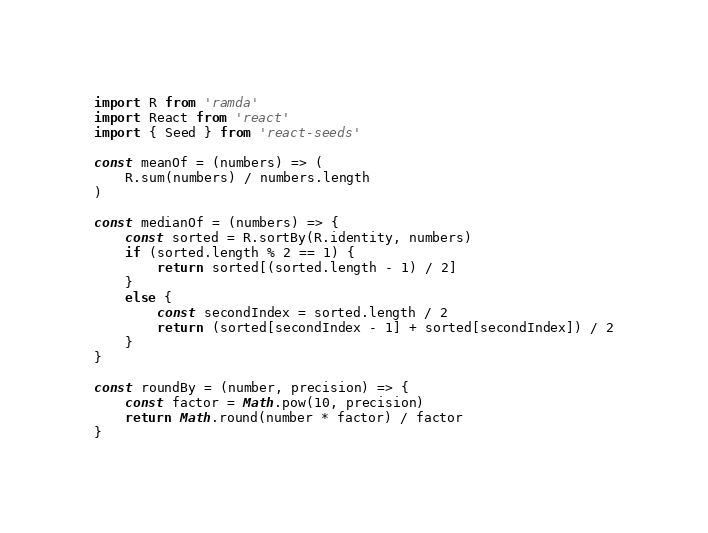Convert code to text. <code><loc_0><loc_0><loc_500><loc_500><_JavaScript_>import R from 'ramda'
import React from 'react'
import { Seed } from 'react-seeds'

const meanOf = (numbers) => (
	R.sum(numbers) / numbers.length
)

const medianOf = (numbers) => {
	const sorted = R.sortBy(R.identity, numbers)
	if (sorted.length % 2 == 1) {
		return sorted[(sorted.length - 1) / 2]
	}
	else {
		const secondIndex = sorted.length / 2 
		return (sorted[secondIndex - 1] + sorted[secondIndex]) / 2
	}
}

const roundBy = (number, precision) => {
	const factor = Math.pow(10, precision)
	return Math.round(number * factor) / factor
}
</code> 